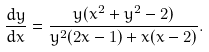<formula> <loc_0><loc_0><loc_500><loc_500>\frac { d y } { d x } = \frac { y ( x ^ { 2 } + y ^ { 2 } - 2 ) } { y ^ { 2 } ( 2 x - 1 ) + x ( x - 2 ) } .</formula> 